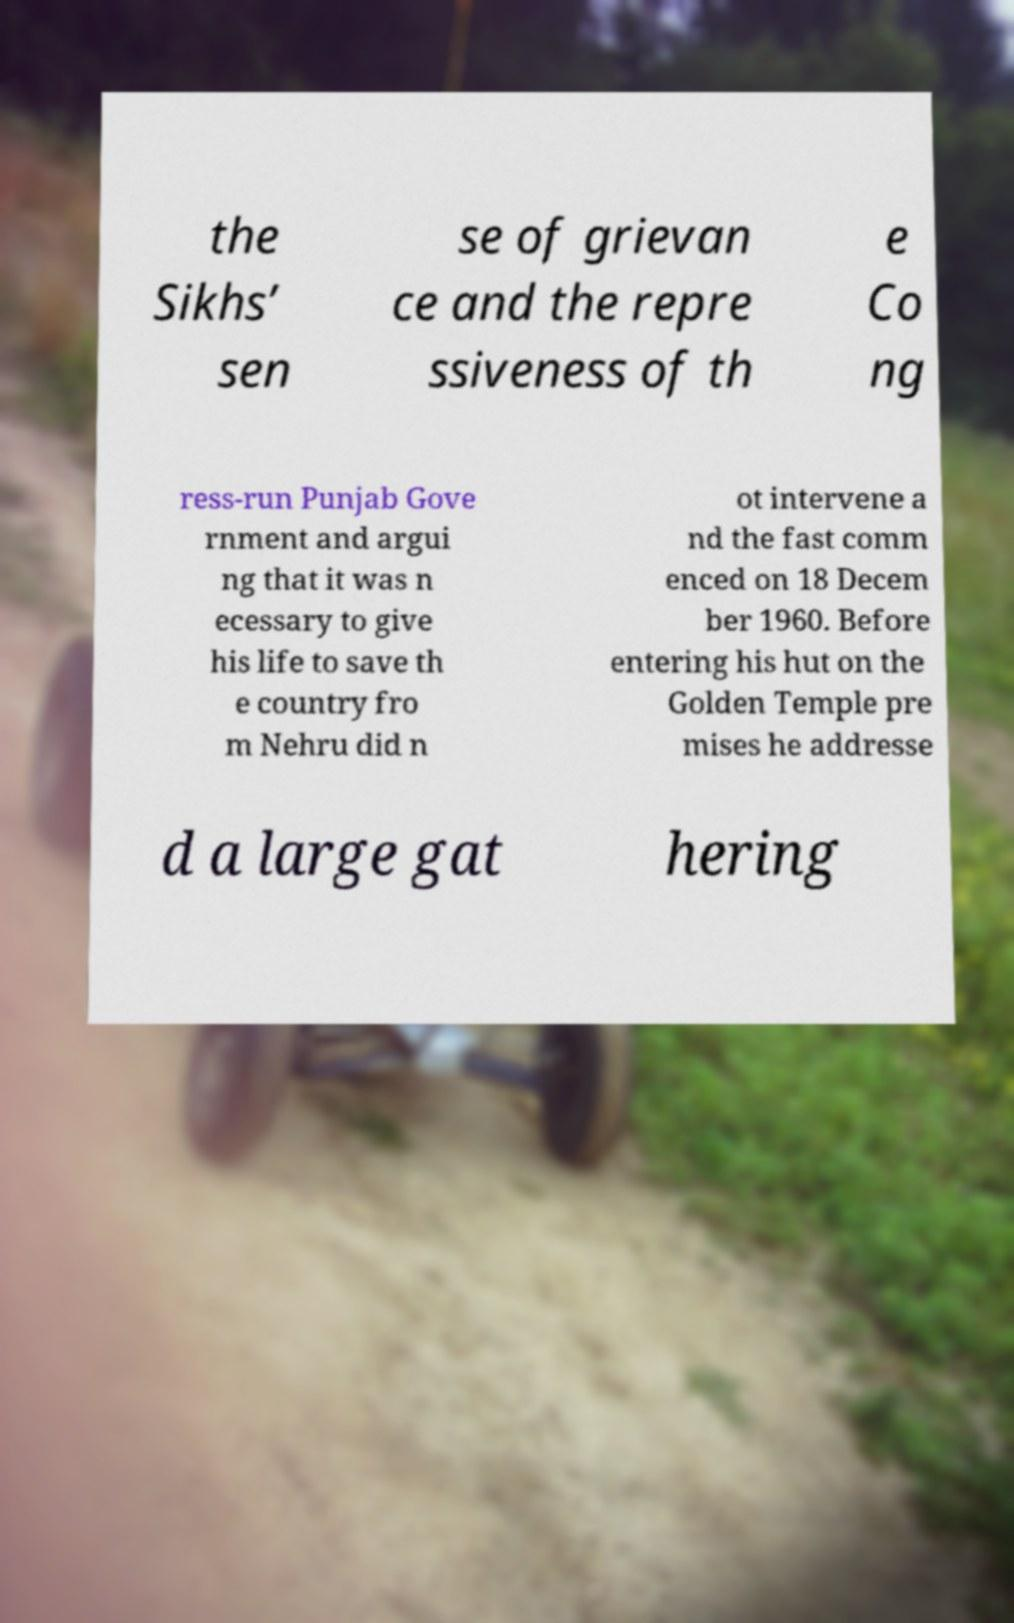For documentation purposes, I need the text within this image transcribed. Could you provide that? the Sikhs’ sen se of grievan ce and the repre ssiveness of th e Co ng ress-run Punjab Gove rnment and argui ng that it was n ecessary to give his life to save th e country fro m Nehru did n ot intervene a nd the fast comm enced on 18 Decem ber 1960. Before entering his hut on the Golden Temple pre mises he addresse d a large gat hering 